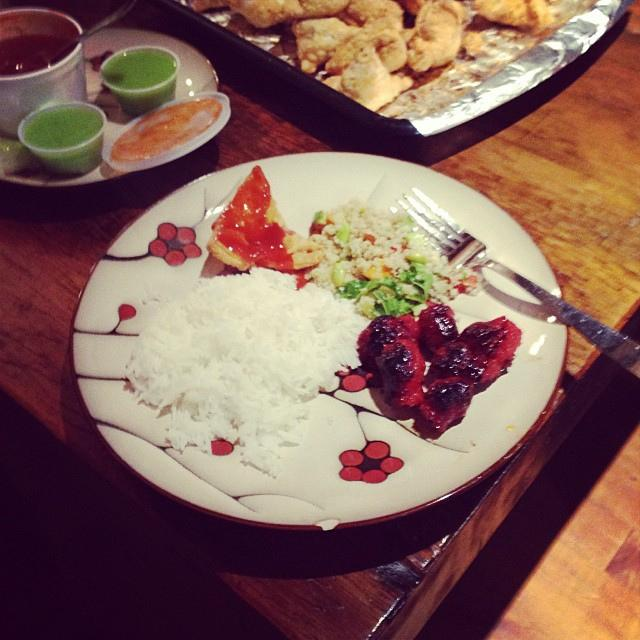How many of the ingredients on the dish were cooked by steaming them? Please explain your reasoning. one. Rice is only one to steam. 